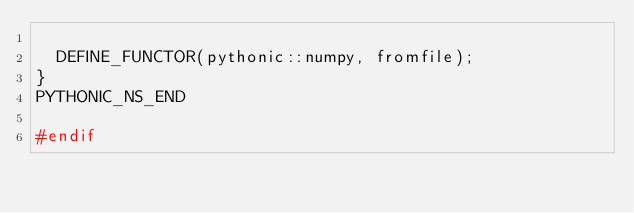<code> <loc_0><loc_0><loc_500><loc_500><_C++_>
  DEFINE_FUNCTOR(pythonic::numpy, fromfile);
}
PYTHONIC_NS_END

#endif
</code> 